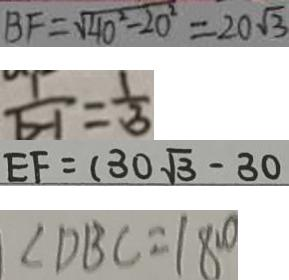<formula> <loc_0><loc_0><loc_500><loc_500>B F = \sqrt { 4 0 ^ { 2 } - 2 0 ^ { 2 } } = 2 0 \sqrt { 3 } 
 \frac { 1 } { b - 1 } = \frac { 1 } { 3 } 
 E F = ( 3 0 \sqrt { 3 } - 3 0 
 \angle D B C = 1 8 0 ^ { \circ }</formula> 